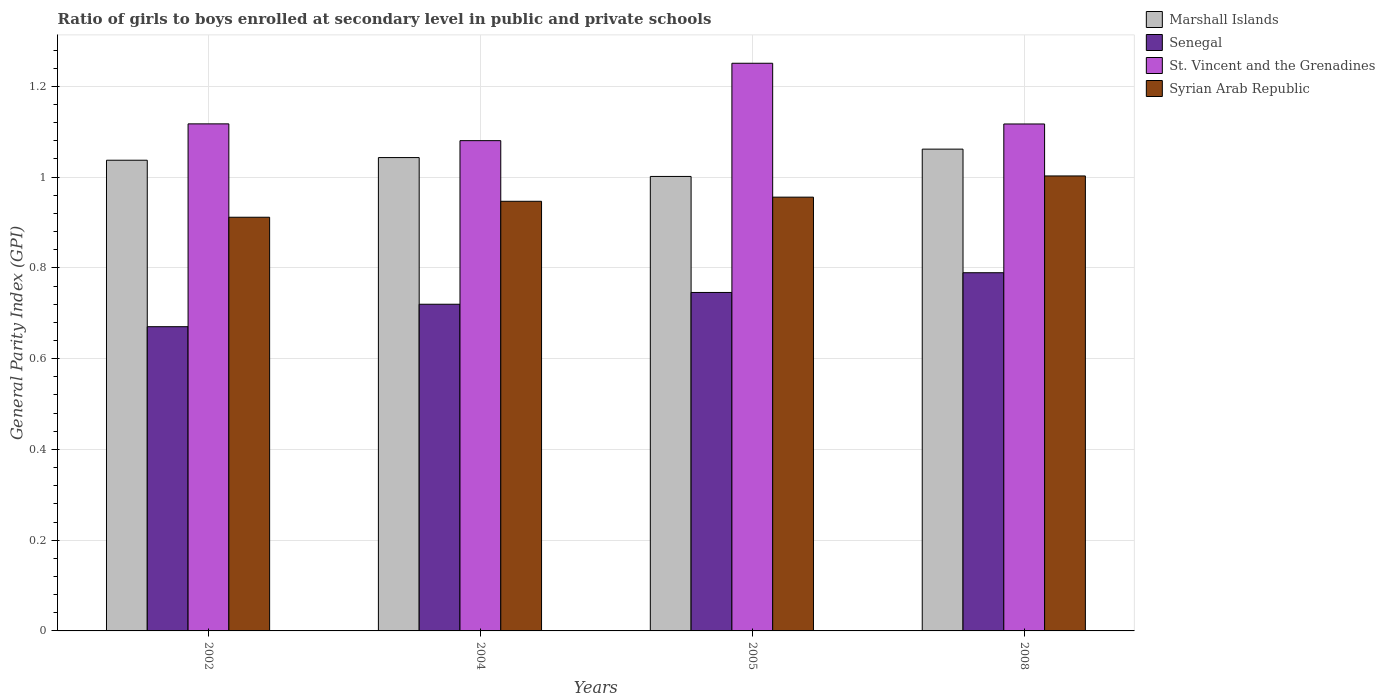How many groups of bars are there?
Your response must be concise. 4. In how many cases, is the number of bars for a given year not equal to the number of legend labels?
Give a very brief answer. 0. What is the general parity index in Marshall Islands in 2002?
Your response must be concise. 1.04. Across all years, what is the maximum general parity index in St. Vincent and the Grenadines?
Your response must be concise. 1.25. Across all years, what is the minimum general parity index in Marshall Islands?
Ensure brevity in your answer.  1. In which year was the general parity index in Marshall Islands minimum?
Your response must be concise. 2005. What is the total general parity index in Senegal in the graph?
Offer a terse response. 2.93. What is the difference between the general parity index in Syrian Arab Republic in 2002 and that in 2005?
Give a very brief answer. -0.04. What is the difference between the general parity index in St. Vincent and the Grenadines in 2008 and the general parity index in Syrian Arab Republic in 2005?
Your answer should be compact. 0.16. What is the average general parity index in Syrian Arab Republic per year?
Provide a succinct answer. 0.95. In the year 2008, what is the difference between the general parity index in Syrian Arab Republic and general parity index in Senegal?
Your answer should be compact. 0.21. In how many years, is the general parity index in Marshall Islands greater than 1.2000000000000002?
Your answer should be very brief. 0. What is the ratio of the general parity index in Marshall Islands in 2004 to that in 2005?
Provide a succinct answer. 1.04. Is the general parity index in Senegal in 2005 less than that in 2008?
Your answer should be very brief. Yes. What is the difference between the highest and the second highest general parity index in Syrian Arab Republic?
Provide a succinct answer. 0.05. What is the difference between the highest and the lowest general parity index in Syrian Arab Republic?
Your answer should be very brief. 0.09. Is it the case that in every year, the sum of the general parity index in Syrian Arab Republic and general parity index in St. Vincent and the Grenadines is greater than the sum of general parity index in Marshall Islands and general parity index in Senegal?
Offer a very short reply. Yes. What does the 3rd bar from the left in 2004 represents?
Offer a terse response. St. Vincent and the Grenadines. What does the 3rd bar from the right in 2002 represents?
Give a very brief answer. Senegal. Is it the case that in every year, the sum of the general parity index in Senegal and general parity index in St. Vincent and the Grenadines is greater than the general parity index in Syrian Arab Republic?
Your answer should be very brief. Yes. Are the values on the major ticks of Y-axis written in scientific E-notation?
Your answer should be compact. No. Does the graph contain any zero values?
Offer a terse response. No. Does the graph contain grids?
Provide a succinct answer. Yes. How many legend labels are there?
Your answer should be compact. 4. What is the title of the graph?
Provide a short and direct response. Ratio of girls to boys enrolled at secondary level in public and private schools. What is the label or title of the Y-axis?
Your answer should be compact. General Parity Index (GPI). What is the General Parity Index (GPI) in Marshall Islands in 2002?
Offer a very short reply. 1.04. What is the General Parity Index (GPI) of Senegal in 2002?
Ensure brevity in your answer.  0.67. What is the General Parity Index (GPI) in St. Vincent and the Grenadines in 2002?
Offer a terse response. 1.12. What is the General Parity Index (GPI) in Syrian Arab Republic in 2002?
Keep it short and to the point. 0.91. What is the General Parity Index (GPI) of Marshall Islands in 2004?
Make the answer very short. 1.04. What is the General Parity Index (GPI) of Senegal in 2004?
Your response must be concise. 0.72. What is the General Parity Index (GPI) of St. Vincent and the Grenadines in 2004?
Make the answer very short. 1.08. What is the General Parity Index (GPI) of Syrian Arab Republic in 2004?
Your answer should be compact. 0.95. What is the General Parity Index (GPI) in Marshall Islands in 2005?
Your answer should be very brief. 1. What is the General Parity Index (GPI) in Senegal in 2005?
Your answer should be very brief. 0.75. What is the General Parity Index (GPI) in St. Vincent and the Grenadines in 2005?
Provide a succinct answer. 1.25. What is the General Parity Index (GPI) of Syrian Arab Republic in 2005?
Ensure brevity in your answer.  0.96. What is the General Parity Index (GPI) of Marshall Islands in 2008?
Give a very brief answer. 1.06. What is the General Parity Index (GPI) of Senegal in 2008?
Provide a succinct answer. 0.79. What is the General Parity Index (GPI) in St. Vincent and the Grenadines in 2008?
Offer a terse response. 1.12. What is the General Parity Index (GPI) of Syrian Arab Republic in 2008?
Keep it short and to the point. 1. Across all years, what is the maximum General Parity Index (GPI) in Marshall Islands?
Offer a very short reply. 1.06. Across all years, what is the maximum General Parity Index (GPI) of Senegal?
Ensure brevity in your answer.  0.79. Across all years, what is the maximum General Parity Index (GPI) in St. Vincent and the Grenadines?
Provide a succinct answer. 1.25. Across all years, what is the maximum General Parity Index (GPI) in Syrian Arab Republic?
Make the answer very short. 1. Across all years, what is the minimum General Parity Index (GPI) in Marshall Islands?
Give a very brief answer. 1. Across all years, what is the minimum General Parity Index (GPI) in Senegal?
Ensure brevity in your answer.  0.67. Across all years, what is the minimum General Parity Index (GPI) of St. Vincent and the Grenadines?
Provide a short and direct response. 1.08. Across all years, what is the minimum General Parity Index (GPI) of Syrian Arab Republic?
Your answer should be compact. 0.91. What is the total General Parity Index (GPI) of Marshall Islands in the graph?
Provide a succinct answer. 4.14. What is the total General Parity Index (GPI) in Senegal in the graph?
Make the answer very short. 2.93. What is the total General Parity Index (GPI) in St. Vincent and the Grenadines in the graph?
Make the answer very short. 4.57. What is the total General Parity Index (GPI) of Syrian Arab Republic in the graph?
Offer a very short reply. 3.82. What is the difference between the General Parity Index (GPI) in Marshall Islands in 2002 and that in 2004?
Offer a terse response. -0.01. What is the difference between the General Parity Index (GPI) in Senegal in 2002 and that in 2004?
Your answer should be compact. -0.05. What is the difference between the General Parity Index (GPI) in St. Vincent and the Grenadines in 2002 and that in 2004?
Your response must be concise. 0.04. What is the difference between the General Parity Index (GPI) of Syrian Arab Republic in 2002 and that in 2004?
Make the answer very short. -0.04. What is the difference between the General Parity Index (GPI) of Marshall Islands in 2002 and that in 2005?
Offer a very short reply. 0.04. What is the difference between the General Parity Index (GPI) of Senegal in 2002 and that in 2005?
Provide a short and direct response. -0.08. What is the difference between the General Parity Index (GPI) of St. Vincent and the Grenadines in 2002 and that in 2005?
Provide a short and direct response. -0.13. What is the difference between the General Parity Index (GPI) of Syrian Arab Republic in 2002 and that in 2005?
Offer a terse response. -0.04. What is the difference between the General Parity Index (GPI) of Marshall Islands in 2002 and that in 2008?
Provide a succinct answer. -0.02. What is the difference between the General Parity Index (GPI) in Senegal in 2002 and that in 2008?
Offer a very short reply. -0.12. What is the difference between the General Parity Index (GPI) in St. Vincent and the Grenadines in 2002 and that in 2008?
Provide a succinct answer. 0. What is the difference between the General Parity Index (GPI) in Syrian Arab Republic in 2002 and that in 2008?
Offer a terse response. -0.09. What is the difference between the General Parity Index (GPI) of Marshall Islands in 2004 and that in 2005?
Ensure brevity in your answer.  0.04. What is the difference between the General Parity Index (GPI) of Senegal in 2004 and that in 2005?
Provide a short and direct response. -0.03. What is the difference between the General Parity Index (GPI) in St. Vincent and the Grenadines in 2004 and that in 2005?
Make the answer very short. -0.17. What is the difference between the General Parity Index (GPI) in Syrian Arab Republic in 2004 and that in 2005?
Offer a very short reply. -0.01. What is the difference between the General Parity Index (GPI) of Marshall Islands in 2004 and that in 2008?
Make the answer very short. -0.02. What is the difference between the General Parity Index (GPI) of Senegal in 2004 and that in 2008?
Provide a succinct answer. -0.07. What is the difference between the General Parity Index (GPI) in St. Vincent and the Grenadines in 2004 and that in 2008?
Provide a short and direct response. -0.04. What is the difference between the General Parity Index (GPI) of Syrian Arab Republic in 2004 and that in 2008?
Provide a succinct answer. -0.06. What is the difference between the General Parity Index (GPI) of Marshall Islands in 2005 and that in 2008?
Your answer should be very brief. -0.06. What is the difference between the General Parity Index (GPI) of Senegal in 2005 and that in 2008?
Make the answer very short. -0.04. What is the difference between the General Parity Index (GPI) of St. Vincent and the Grenadines in 2005 and that in 2008?
Keep it short and to the point. 0.13. What is the difference between the General Parity Index (GPI) in Syrian Arab Republic in 2005 and that in 2008?
Offer a very short reply. -0.05. What is the difference between the General Parity Index (GPI) in Marshall Islands in 2002 and the General Parity Index (GPI) in Senegal in 2004?
Provide a short and direct response. 0.32. What is the difference between the General Parity Index (GPI) in Marshall Islands in 2002 and the General Parity Index (GPI) in St. Vincent and the Grenadines in 2004?
Give a very brief answer. -0.04. What is the difference between the General Parity Index (GPI) in Marshall Islands in 2002 and the General Parity Index (GPI) in Syrian Arab Republic in 2004?
Give a very brief answer. 0.09. What is the difference between the General Parity Index (GPI) in Senegal in 2002 and the General Parity Index (GPI) in St. Vincent and the Grenadines in 2004?
Provide a succinct answer. -0.41. What is the difference between the General Parity Index (GPI) in Senegal in 2002 and the General Parity Index (GPI) in Syrian Arab Republic in 2004?
Your answer should be very brief. -0.28. What is the difference between the General Parity Index (GPI) in St. Vincent and the Grenadines in 2002 and the General Parity Index (GPI) in Syrian Arab Republic in 2004?
Ensure brevity in your answer.  0.17. What is the difference between the General Parity Index (GPI) in Marshall Islands in 2002 and the General Parity Index (GPI) in Senegal in 2005?
Offer a very short reply. 0.29. What is the difference between the General Parity Index (GPI) in Marshall Islands in 2002 and the General Parity Index (GPI) in St. Vincent and the Grenadines in 2005?
Keep it short and to the point. -0.21. What is the difference between the General Parity Index (GPI) in Marshall Islands in 2002 and the General Parity Index (GPI) in Syrian Arab Republic in 2005?
Your response must be concise. 0.08. What is the difference between the General Parity Index (GPI) in Senegal in 2002 and the General Parity Index (GPI) in St. Vincent and the Grenadines in 2005?
Offer a terse response. -0.58. What is the difference between the General Parity Index (GPI) in Senegal in 2002 and the General Parity Index (GPI) in Syrian Arab Republic in 2005?
Ensure brevity in your answer.  -0.29. What is the difference between the General Parity Index (GPI) of St. Vincent and the Grenadines in 2002 and the General Parity Index (GPI) of Syrian Arab Republic in 2005?
Your answer should be very brief. 0.16. What is the difference between the General Parity Index (GPI) in Marshall Islands in 2002 and the General Parity Index (GPI) in Senegal in 2008?
Keep it short and to the point. 0.25. What is the difference between the General Parity Index (GPI) in Marshall Islands in 2002 and the General Parity Index (GPI) in St. Vincent and the Grenadines in 2008?
Make the answer very short. -0.08. What is the difference between the General Parity Index (GPI) of Marshall Islands in 2002 and the General Parity Index (GPI) of Syrian Arab Republic in 2008?
Your response must be concise. 0.03. What is the difference between the General Parity Index (GPI) of Senegal in 2002 and the General Parity Index (GPI) of St. Vincent and the Grenadines in 2008?
Give a very brief answer. -0.45. What is the difference between the General Parity Index (GPI) in Senegal in 2002 and the General Parity Index (GPI) in Syrian Arab Republic in 2008?
Keep it short and to the point. -0.33. What is the difference between the General Parity Index (GPI) of St. Vincent and the Grenadines in 2002 and the General Parity Index (GPI) of Syrian Arab Republic in 2008?
Make the answer very short. 0.11. What is the difference between the General Parity Index (GPI) in Marshall Islands in 2004 and the General Parity Index (GPI) in Senegal in 2005?
Your answer should be very brief. 0.3. What is the difference between the General Parity Index (GPI) in Marshall Islands in 2004 and the General Parity Index (GPI) in St. Vincent and the Grenadines in 2005?
Your response must be concise. -0.21. What is the difference between the General Parity Index (GPI) of Marshall Islands in 2004 and the General Parity Index (GPI) of Syrian Arab Republic in 2005?
Give a very brief answer. 0.09. What is the difference between the General Parity Index (GPI) of Senegal in 2004 and the General Parity Index (GPI) of St. Vincent and the Grenadines in 2005?
Ensure brevity in your answer.  -0.53. What is the difference between the General Parity Index (GPI) of Senegal in 2004 and the General Parity Index (GPI) of Syrian Arab Republic in 2005?
Your answer should be very brief. -0.24. What is the difference between the General Parity Index (GPI) of St. Vincent and the Grenadines in 2004 and the General Parity Index (GPI) of Syrian Arab Republic in 2005?
Give a very brief answer. 0.12. What is the difference between the General Parity Index (GPI) in Marshall Islands in 2004 and the General Parity Index (GPI) in Senegal in 2008?
Provide a short and direct response. 0.25. What is the difference between the General Parity Index (GPI) of Marshall Islands in 2004 and the General Parity Index (GPI) of St. Vincent and the Grenadines in 2008?
Make the answer very short. -0.07. What is the difference between the General Parity Index (GPI) in Marshall Islands in 2004 and the General Parity Index (GPI) in Syrian Arab Republic in 2008?
Ensure brevity in your answer.  0.04. What is the difference between the General Parity Index (GPI) in Senegal in 2004 and the General Parity Index (GPI) in St. Vincent and the Grenadines in 2008?
Your response must be concise. -0.4. What is the difference between the General Parity Index (GPI) of Senegal in 2004 and the General Parity Index (GPI) of Syrian Arab Republic in 2008?
Ensure brevity in your answer.  -0.28. What is the difference between the General Parity Index (GPI) of St. Vincent and the Grenadines in 2004 and the General Parity Index (GPI) of Syrian Arab Republic in 2008?
Provide a succinct answer. 0.08. What is the difference between the General Parity Index (GPI) of Marshall Islands in 2005 and the General Parity Index (GPI) of Senegal in 2008?
Offer a terse response. 0.21. What is the difference between the General Parity Index (GPI) of Marshall Islands in 2005 and the General Parity Index (GPI) of St. Vincent and the Grenadines in 2008?
Your response must be concise. -0.12. What is the difference between the General Parity Index (GPI) in Marshall Islands in 2005 and the General Parity Index (GPI) in Syrian Arab Republic in 2008?
Your answer should be very brief. -0. What is the difference between the General Parity Index (GPI) of Senegal in 2005 and the General Parity Index (GPI) of St. Vincent and the Grenadines in 2008?
Provide a succinct answer. -0.37. What is the difference between the General Parity Index (GPI) in Senegal in 2005 and the General Parity Index (GPI) in Syrian Arab Republic in 2008?
Provide a succinct answer. -0.26. What is the difference between the General Parity Index (GPI) in St. Vincent and the Grenadines in 2005 and the General Parity Index (GPI) in Syrian Arab Republic in 2008?
Your answer should be very brief. 0.25. What is the average General Parity Index (GPI) in Marshall Islands per year?
Give a very brief answer. 1.04. What is the average General Parity Index (GPI) in Senegal per year?
Offer a terse response. 0.73. What is the average General Parity Index (GPI) in St. Vincent and the Grenadines per year?
Ensure brevity in your answer.  1.14. What is the average General Parity Index (GPI) in Syrian Arab Republic per year?
Keep it short and to the point. 0.95. In the year 2002, what is the difference between the General Parity Index (GPI) in Marshall Islands and General Parity Index (GPI) in Senegal?
Your response must be concise. 0.37. In the year 2002, what is the difference between the General Parity Index (GPI) in Marshall Islands and General Parity Index (GPI) in St. Vincent and the Grenadines?
Your response must be concise. -0.08. In the year 2002, what is the difference between the General Parity Index (GPI) of Marshall Islands and General Parity Index (GPI) of Syrian Arab Republic?
Give a very brief answer. 0.13. In the year 2002, what is the difference between the General Parity Index (GPI) of Senegal and General Parity Index (GPI) of St. Vincent and the Grenadines?
Make the answer very short. -0.45. In the year 2002, what is the difference between the General Parity Index (GPI) in Senegal and General Parity Index (GPI) in Syrian Arab Republic?
Provide a short and direct response. -0.24. In the year 2002, what is the difference between the General Parity Index (GPI) of St. Vincent and the Grenadines and General Parity Index (GPI) of Syrian Arab Republic?
Make the answer very short. 0.21. In the year 2004, what is the difference between the General Parity Index (GPI) of Marshall Islands and General Parity Index (GPI) of Senegal?
Offer a terse response. 0.32. In the year 2004, what is the difference between the General Parity Index (GPI) in Marshall Islands and General Parity Index (GPI) in St. Vincent and the Grenadines?
Your response must be concise. -0.04. In the year 2004, what is the difference between the General Parity Index (GPI) in Marshall Islands and General Parity Index (GPI) in Syrian Arab Republic?
Give a very brief answer. 0.1. In the year 2004, what is the difference between the General Parity Index (GPI) of Senegal and General Parity Index (GPI) of St. Vincent and the Grenadines?
Keep it short and to the point. -0.36. In the year 2004, what is the difference between the General Parity Index (GPI) of Senegal and General Parity Index (GPI) of Syrian Arab Republic?
Ensure brevity in your answer.  -0.23. In the year 2004, what is the difference between the General Parity Index (GPI) of St. Vincent and the Grenadines and General Parity Index (GPI) of Syrian Arab Republic?
Provide a succinct answer. 0.13. In the year 2005, what is the difference between the General Parity Index (GPI) in Marshall Islands and General Parity Index (GPI) in Senegal?
Give a very brief answer. 0.26. In the year 2005, what is the difference between the General Parity Index (GPI) in Marshall Islands and General Parity Index (GPI) in St. Vincent and the Grenadines?
Your answer should be very brief. -0.25. In the year 2005, what is the difference between the General Parity Index (GPI) of Marshall Islands and General Parity Index (GPI) of Syrian Arab Republic?
Offer a very short reply. 0.05. In the year 2005, what is the difference between the General Parity Index (GPI) of Senegal and General Parity Index (GPI) of St. Vincent and the Grenadines?
Give a very brief answer. -0.51. In the year 2005, what is the difference between the General Parity Index (GPI) of Senegal and General Parity Index (GPI) of Syrian Arab Republic?
Ensure brevity in your answer.  -0.21. In the year 2005, what is the difference between the General Parity Index (GPI) of St. Vincent and the Grenadines and General Parity Index (GPI) of Syrian Arab Republic?
Your answer should be compact. 0.3. In the year 2008, what is the difference between the General Parity Index (GPI) in Marshall Islands and General Parity Index (GPI) in Senegal?
Provide a short and direct response. 0.27. In the year 2008, what is the difference between the General Parity Index (GPI) in Marshall Islands and General Parity Index (GPI) in St. Vincent and the Grenadines?
Your response must be concise. -0.06. In the year 2008, what is the difference between the General Parity Index (GPI) of Marshall Islands and General Parity Index (GPI) of Syrian Arab Republic?
Give a very brief answer. 0.06. In the year 2008, what is the difference between the General Parity Index (GPI) of Senegal and General Parity Index (GPI) of St. Vincent and the Grenadines?
Make the answer very short. -0.33. In the year 2008, what is the difference between the General Parity Index (GPI) of Senegal and General Parity Index (GPI) of Syrian Arab Republic?
Provide a succinct answer. -0.21. In the year 2008, what is the difference between the General Parity Index (GPI) in St. Vincent and the Grenadines and General Parity Index (GPI) in Syrian Arab Republic?
Provide a short and direct response. 0.11. What is the ratio of the General Parity Index (GPI) in Marshall Islands in 2002 to that in 2004?
Give a very brief answer. 0.99. What is the ratio of the General Parity Index (GPI) of Senegal in 2002 to that in 2004?
Make the answer very short. 0.93. What is the ratio of the General Parity Index (GPI) in St. Vincent and the Grenadines in 2002 to that in 2004?
Offer a terse response. 1.03. What is the ratio of the General Parity Index (GPI) of Syrian Arab Republic in 2002 to that in 2004?
Offer a very short reply. 0.96. What is the ratio of the General Parity Index (GPI) of Marshall Islands in 2002 to that in 2005?
Provide a short and direct response. 1.04. What is the ratio of the General Parity Index (GPI) in Senegal in 2002 to that in 2005?
Provide a short and direct response. 0.9. What is the ratio of the General Parity Index (GPI) in St. Vincent and the Grenadines in 2002 to that in 2005?
Your response must be concise. 0.89. What is the ratio of the General Parity Index (GPI) in Syrian Arab Republic in 2002 to that in 2005?
Your answer should be compact. 0.95. What is the ratio of the General Parity Index (GPI) of Senegal in 2002 to that in 2008?
Provide a short and direct response. 0.85. What is the ratio of the General Parity Index (GPI) in St. Vincent and the Grenadines in 2002 to that in 2008?
Offer a terse response. 1. What is the ratio of the General Parity Index (GPI) of Syrian Arab Republic in 2002 to that in 2008?
Offer a very short reply. 0.91. What is the ratio of the General Parity Index (GPI) in Marshall Islands in 2004 to that in 2005?
Give a very brief answer. 1.04. What is the ratio of the General Parity Index (GPI) of Senegal in 2004 to that in 2005?
Offer a terse response. 0.97. What is the ratio of the General Parity Index (GPI) of St. Vincent and the Grenadines in 2004 to that in 2005?
Give a very brief answer. 0.86. What is the ratio of the General Parity Index (GPI) in Marshall Islands in 2004 to that in 2008?
Your response must be concise. 0.98. What is the ratio of the General Parity Index (GPI) in Senegal in 2004 to that in 2008?
Your response must be concise. 0.91. What is the ratio of the General Parity Index (GPI) in St. Vincent and the Grenadines in 2004 to that in 2008?
Give a very brief answer. 0.97. What is the ratio of the General Parity Index (GPI) in Syrian Arab Republic in 2004 to that in 2008?
Offer a terse response. 0.94. What is the ratio of the General Parity Index (GPI) of Marshall Islands in 2005 to that in 2008?
Give a very brief answer. 0.94. What is the ratio of the General Parity Index (GPI) in Senegal in 2005 to that in 2008?
Give a very brief answer. 0.94. What is the ratio of the General Parity Index (GPI) in St. Vincent and the Grenadines in 2005 to that in 2008?
Your answer should be compact. 1.12. What is the ratio of the General Parity Index (GPI) in Syrian Arab Republic in 2005 to that in 2008?
Give a very brief answer. 0.95. What is the difference between the highest and the second highest General Parity Index (GPI) of Marshall Islands?
Give a very brief answer. 0.02. What is the difference between the highest and the second highest General Parity Index (GPI) in Senegal?
Offer a very short reply. 0.04. What is the difference between the highest and the second highest General Parity Index (GPI) in St. Vincent and the Grenadines?
Offer a terse response. 0.13. What is the difference between the highest and the second highest General Parity Index (GPI) of Syrian Arab Republic?
Your answer should be compact. 0.05. What is the difference between the highest and the lowest General Parity Index (GPI) of Marshall Islands?
Ensure brevity in your answer.  0.06. What is the difference between the highest and the lowest General Parity Index (GPI) of Senegal?
Offer a terse response. 0.12. What is the difference between the highest and the lowest General Parity Index (GPI) of St. Vincent and the Grenadines?
Ensure brevity in your answer.  0.17. What is the difference between the highest and the lowest General Parity Index (GPI) in Syrian Arab Republic?
Your response must be concise. 0.09. 